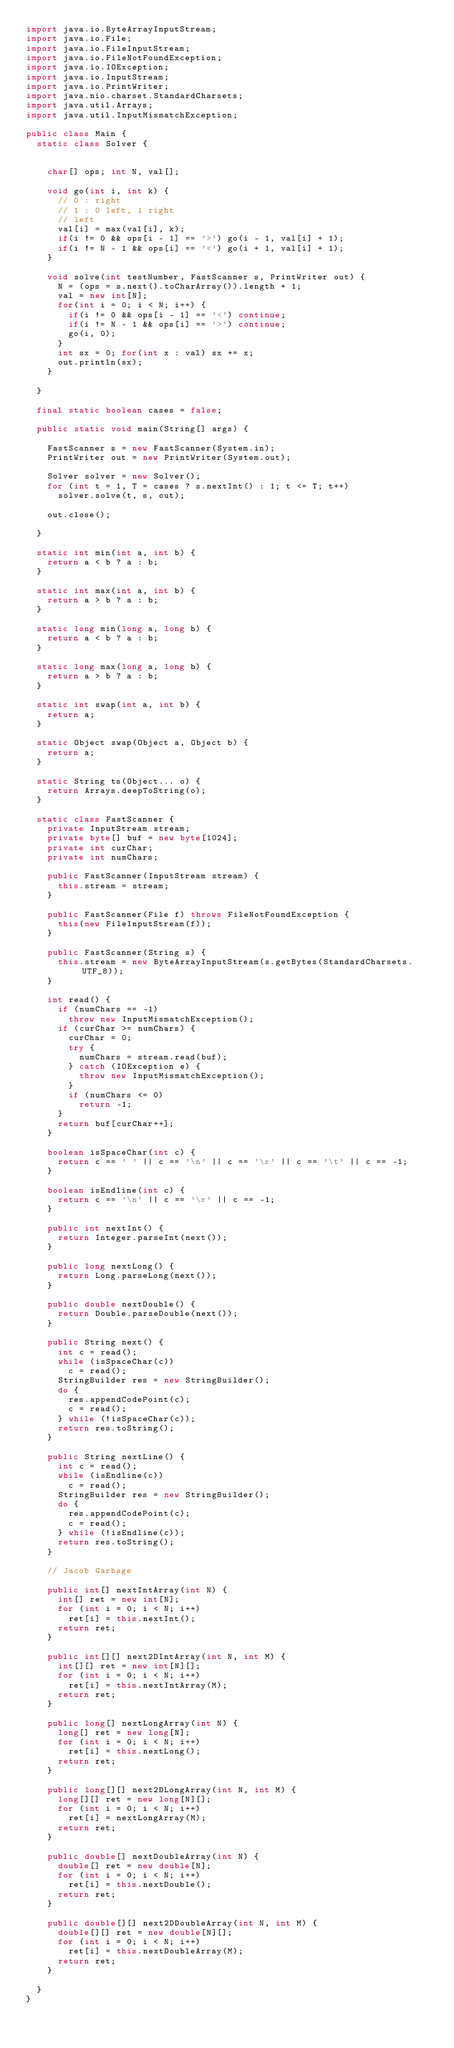Convert code to text. <code><loc_0><loc_0><loc_500><loc_500><_Java_>import java.io.ByteArrayInputStream;
import java.io.File;
import java.io.FileInputStream;
import java.io.FileNotFoundException;
import java.io.IOException;
import java.io.InputStream;
import java.io.PrintWriter;
import java.nio.charset.StandardCharsets;
import java.util.Arrays;
import java.util.InputMismatchException;

public class Main {
	static class Solver {

		
		char[] ops; int N, val[];
		
		void go(int i, int k) {
			// 0 : right
			// 1 : 0 left, 1 right
			// left
			val[i] = max(val[i], k);
			if(i != 0 && ops[i - 1] == '>') go(i - 1, val[i] + 1);
			if(i != N - 1 && ops[i] == '<') go(i + 1, val[i] + 1);
		}
		
		void solve(int testNumber, FastScanner s, PrintWriter out) {
			N = (ops = s.next().toCharArray()).length + 1;
			val = new int[N];
			for(int i = 0; i < N; i++) {
				if(i != 0 && ops[i - 1] == '<') continue;
				if(i != N - 1 && ops[i] == '>') continue;
				go(i, 0);
			}
			int sx = 0; for(int x : val) sx += x;
			out.println(sx);
		}

	}

	final static boolean cases = false;

	public static void main(String[] args) {

		FastScanner s = new FastScanner(System.in);
		PrintWriter out = new PrintWriter(System.out);

		Solver solver = new Solver();
		for (int t = 1, T = cases ? s.nextInt() : 1; t <= T; t++)
			solver.solve(t, s, out);

		out.close();

	}

	static int min(int a, int b) {
		return a < b ? a : b;
	}

	static int max(int a, int b) {
		return a > b ? a : b;
	}

	static long min(long a, long b) {
		return a < b ? a : b;
	}

	static long max(long a, long b) {
		return a > b ? a : b;
	}

	static int swap(int a, int b) {
		return a;
	}

	static Object swap(Object a, Object b) {
		return a;
	}

	static String ts(Object... o) {
		return Arrays.deepToString(o);
	}

	static class FastScanner {
		private InputStream stream;
		private byte[] buf = new byte[1024];
		private int curChar;
		private int numChars;

		public FastScanner(InputStream stream) {
			this.stream = stream;
		}

		public FastScanner(File f) throws FileNotFoundException {
			this(new FileInputStream(f));
		}

		public FastScanner(String s) {
			this.stream = new ByteArrayInputStream(s.getBytes(StandardCharsets.UTF_8));
		}

		int read() {
			if (numChars == -1)
				throw new InputMismatchException();
			if (curChar >= numChars) {
				curChar = 0;
				try {
					numChars = stream.read(buf);
				} catch (IOException e) {
					throw new InputMismatchException();
				}
				if (numChars <= 0)
					return -1;
			}
			return buf[curChar++];
		}

		boolean isSpaceChar(int c) {
			return c == ' ' || c == '\n' || c == '\r' || c == '\t' || c == -1;
		}

		boolean isEndline(int c) {
			return c == '\n' || c == '\r' || c == -1;
		}

		public int nextInt() {
			return Integer.parseInt(next());
		}

		public long nextLong() {
			return Long.parseLong(next());
		}

		public double nextDouble() {
			return Double.parseDouble(next());
		}

		public String next() {
			int c = read();
			while (isSpaceChar(c))
				c = read();
			StringBuilder res = new StringBuilder();
			do {
				res.appendCodePoint(c);
				c = read();
			} while (!isSpaceChar(c));
			return res.toString();
		}

		public String nextLine() {
			int c = read();
			while (isEndline(c))
				c = read();
			StringBuilder res = new StringBuilder();
			do {
				res.appendCodePoint(c);
				c = read();
			} while (!isEndline(c));
			return res.toString();
		}

		// Jacob Garbage

		public int[] nextIntArray(int N) {
			int[] ret = new int[N];
			for (int i = 0; i < N; i++)
				ret[i] = this.nextInt();
			return ret;
		}

		public int[][] next2DIntArray(int N, int M) {
			int[][] ret = new int[N][];
			for (int i = 0; i < N; i++)
				ret[i] = this.nextIntArray(M);
			return ret;
		}

		public long[] nextLongArray(int N) {
			long[] ret = new long[N];
			for (int i = 0; i < N; i++)
				ret[i] = this.nextLong();
			return ret;
		}

		public long[][] next2DLongArray(int N, int M) {
			long[][] ret = new long[N][];
			for (int i = 0; i < N; i++)
				ret[i] = nextLongArray(M);
			return ret;
		}

		public double[] nextDoubleArray(int N) {
			double[] ret = new double[N];
			for (int i = 0; i < N; i++)
				ret[i] = this.nextDouble();
			return ret;
		}

		public double[][] next2DDoubleArray(int N, int M) {
			double[][] ret = new double[N][];
			for (int i = 0; i < N; i++)
				ret[i] = this.nextDoubleArray(M);
			return ret;
		}

	}
}
</code> 